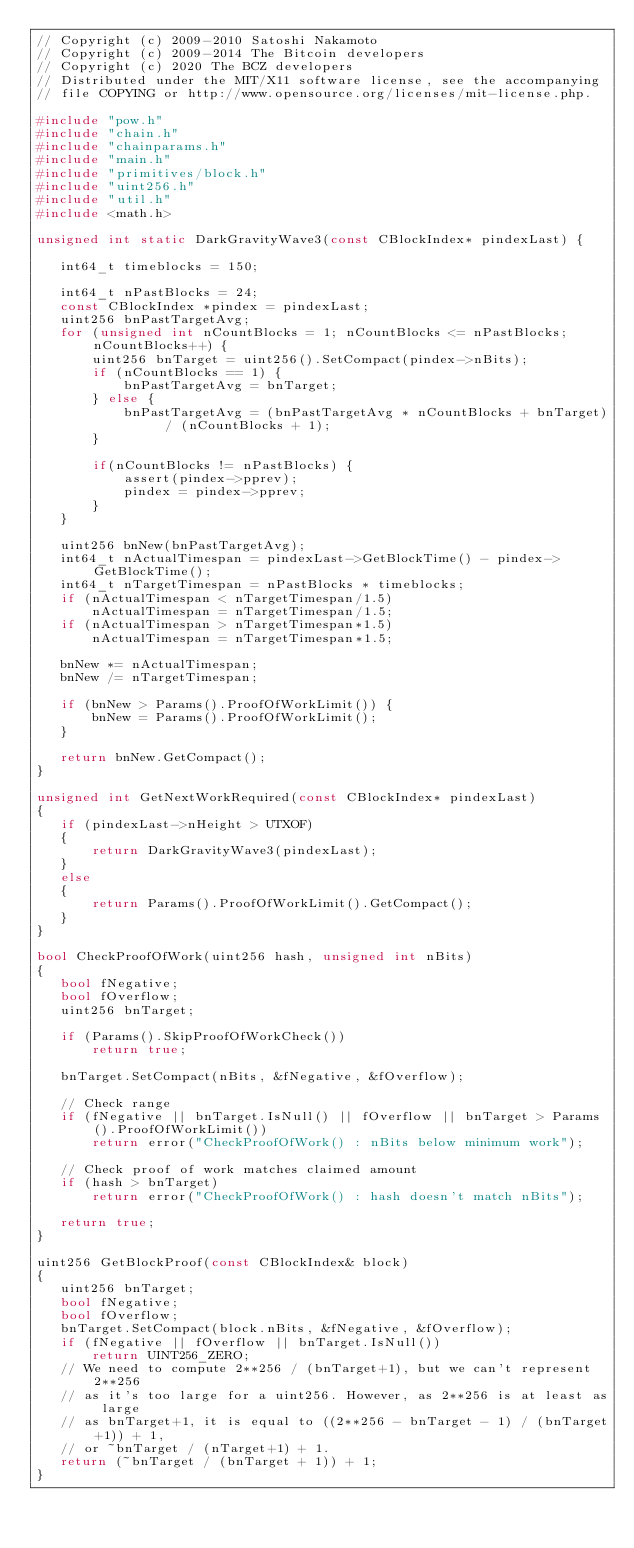<code> <loc_0><loc_0><loc_500><loc_500><_C++_>// Copyright (c) 2009-2010 Satoshi Nakamoto
// Copyright (c) 2009-2014 The Bitcoin developers
// Copyright (c) 2020 The BCZ developers
// Distributed under the MIT/X11 software license, see the accompanying
// file COPYING or http://www.opensource.org/licenses/mit-license.php.

#include "pow.h"
#include "chain.h"
#include "chainparams.h"
#include "main.h"
#include "primitives/block.h"
#include "uint256.h"
#include "util.h"
#include <math.h>

unsigned int static DarkGravityWave3(const CBlockIndex* pindexLast) {

   int64_t timeblocks = 150;

   int64_t nPastBlocks = 24;
   const CBlockIndex *pindex = pindexLast;
   uint256 bnPastTargetAvg;
   for (unsigned int nCountBlocks = 1; nCountBlocks <= nPastBlocks; nCountBlocks++) {
       uint256 bnTarget = uint256().SetCompact(pindex->nBits);
       if (nCountBlocks == 1) {
           bnPastTargetAvg = bnTarget;
       } else {
           bnPastTargetAvg = (bnPastTargetAvg * nCountBlocks + bnTarget) / (nCountBlocks + 1);
       }

       if(nCountBlocks != nPastBlocks) {
           assert(pindex->pprev);
           pindex = pindex->pprev;
       }
   }

   uint256 bnNew(bnPastTargetAvg);
   int64_t nActualTimespan = pindexLast->GetBlockTime() - pindex->GetBlockTime();
   int64_t nTargetTimespan = nPastBlocks * timeblocks;
   if (nActualTimespan < nTargetTimespan/1.5)
       nActualTimespan = nTargetTimespan/1.5;
   if (nActualTimespan > nTargetTimespan*1.5)
       nActualTimespan = nTargetTimespan*1.5;

   bnNew *= nActualTimespan;
   bnNew /= nTargetTimespan;

   if (bnNew > Params().ProofOfWorkLimit()) {
       bnNew = Params().ProofOfWorkLimit();
   }

   return bnNew.GetCompact();
}

unsigned int GetNextWorkRequired(const CBlockIndex* pindexLast)
{
   if (pindexLast->nHeight > UTXOF)
   {
       return DarkGravityWave3(pindexLast);
   }
   else
   {
       return Params().ProofOfWorkLimit().GetCompact();
   }
}

bool CheckProofOfWork(uint256 hash, unsigned int nBits)
{
   bool fNegative;
   bool fOverflow;
   uint256 bnTarget;

   if (Params().SkipProofOfWorkCheck())
       return true;

   bnTarget.SetCompact(nBits, &fNegative, &fOverflow);

   // Check range
   if (fNegative || bnTarget.IsNull() || fOverflow || bnTarget > Params().ProofOfWorkLimit())
       return error("CheckProofOfWork() : nBits below minimum work");

   // Check proof of work matches claimed amount
   if (hash > bnTarget)
       return error("CheckProofOfWork() : hash doesn't match nBits");

   return true;
}

uint256 GetBlockProof(const CBlockIndex& block)
{
   uint256 bnTarget;
   bool fNegative;
   bool fOverflow;
   bnTarget.SetCompact(block.nBits, &fNegative, &fOverflow);
   if (fNegative || fOverflow || bnTarget.IsNull())
       return UINT256_ZERO;
   // We need to compute 2**256 / (bnTarget+1), but we can't represent 2**256
   // as it's too large for a uint256. However, as 2**256 is at least as large
   // as bnTarget+1, it is equal to ((2**256 - bnTarget - 1) / (bnTarget+1)) + 1,
   // or ~bnTarget / (nTarget+1) + 1.
   return (~bnTarget / (bnTarget + 1)) + 1;
}
</code> 